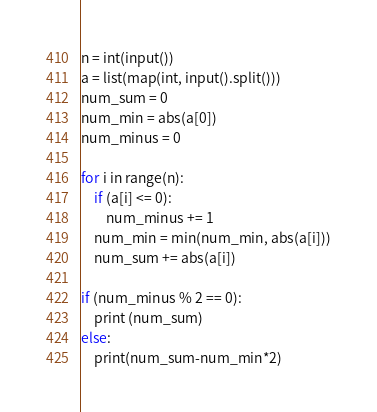Convert code to text. <code><loc_0><loc_0><loc_500><loc_500><_Python_>n = int(input())
a = list(map(int, input().split()))
num_sum = 0
num_min = abs(a[0])
num_minus = 0

for i in range(n):
    if (a[i] <= 0):
        num_minus += 1
    num_min = min(num_min, abs(a[i]))
    num_sum += abs(a[i])

if (num_minus % 2 == 0):
    print (num_sum)
else:
    print(num_sum-num_min*2)
</code> 